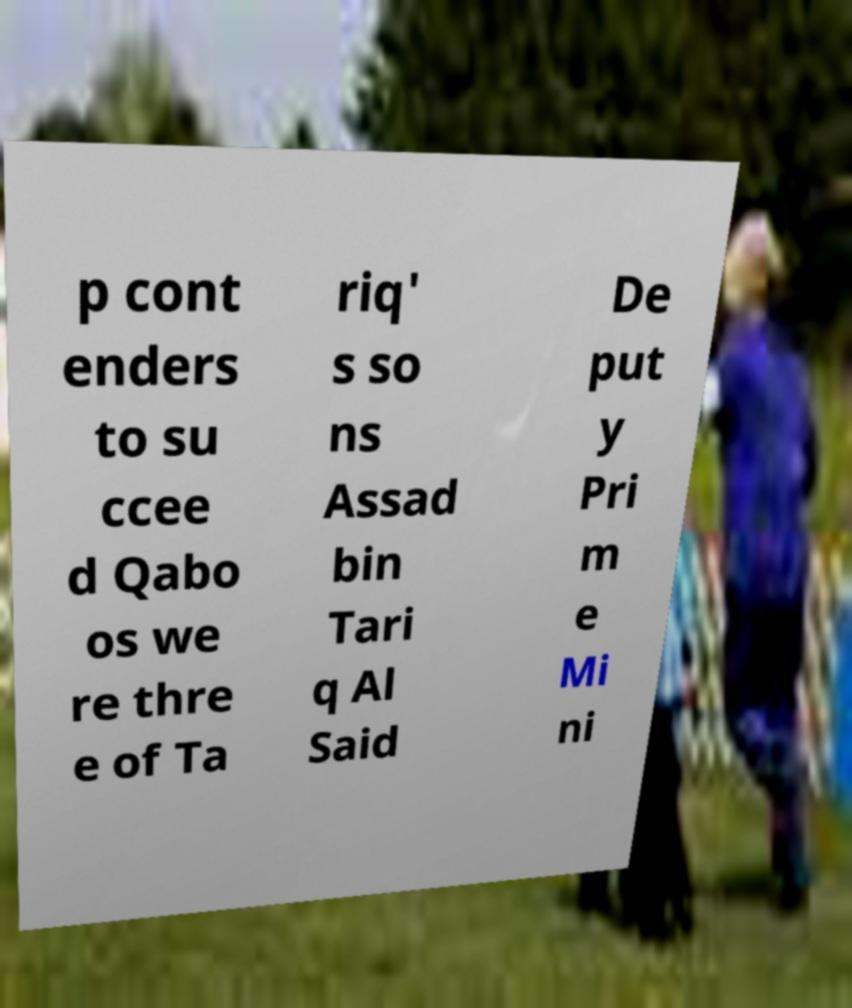Please identify and transcribe the text found in this image. p cont enders to su ccee d Qabo os we re thre e of Ta riq' s so ns Assad bin Tari q Al Said De put y Pri m e Mi ni 